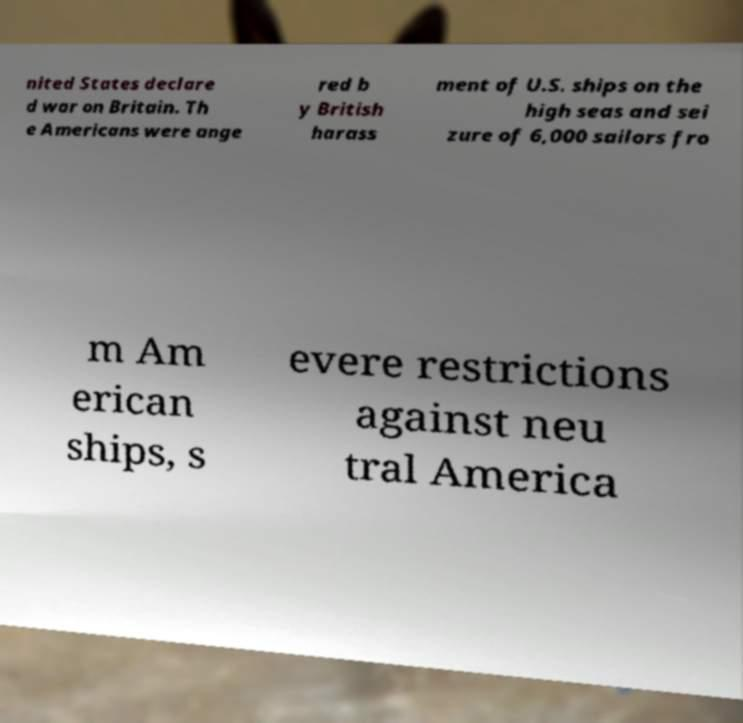Can you read and provide the text displayed in the image?This photo seems to have some interesting text. Can you extract and type it out for me? nited States declare d war on Britain. Th e Americans were ange red b y British harass ment of U.S. ships on the high seas and sei zure of 6,000 sailors fro m Am erican ships, s evere restrictions against neu tral America 